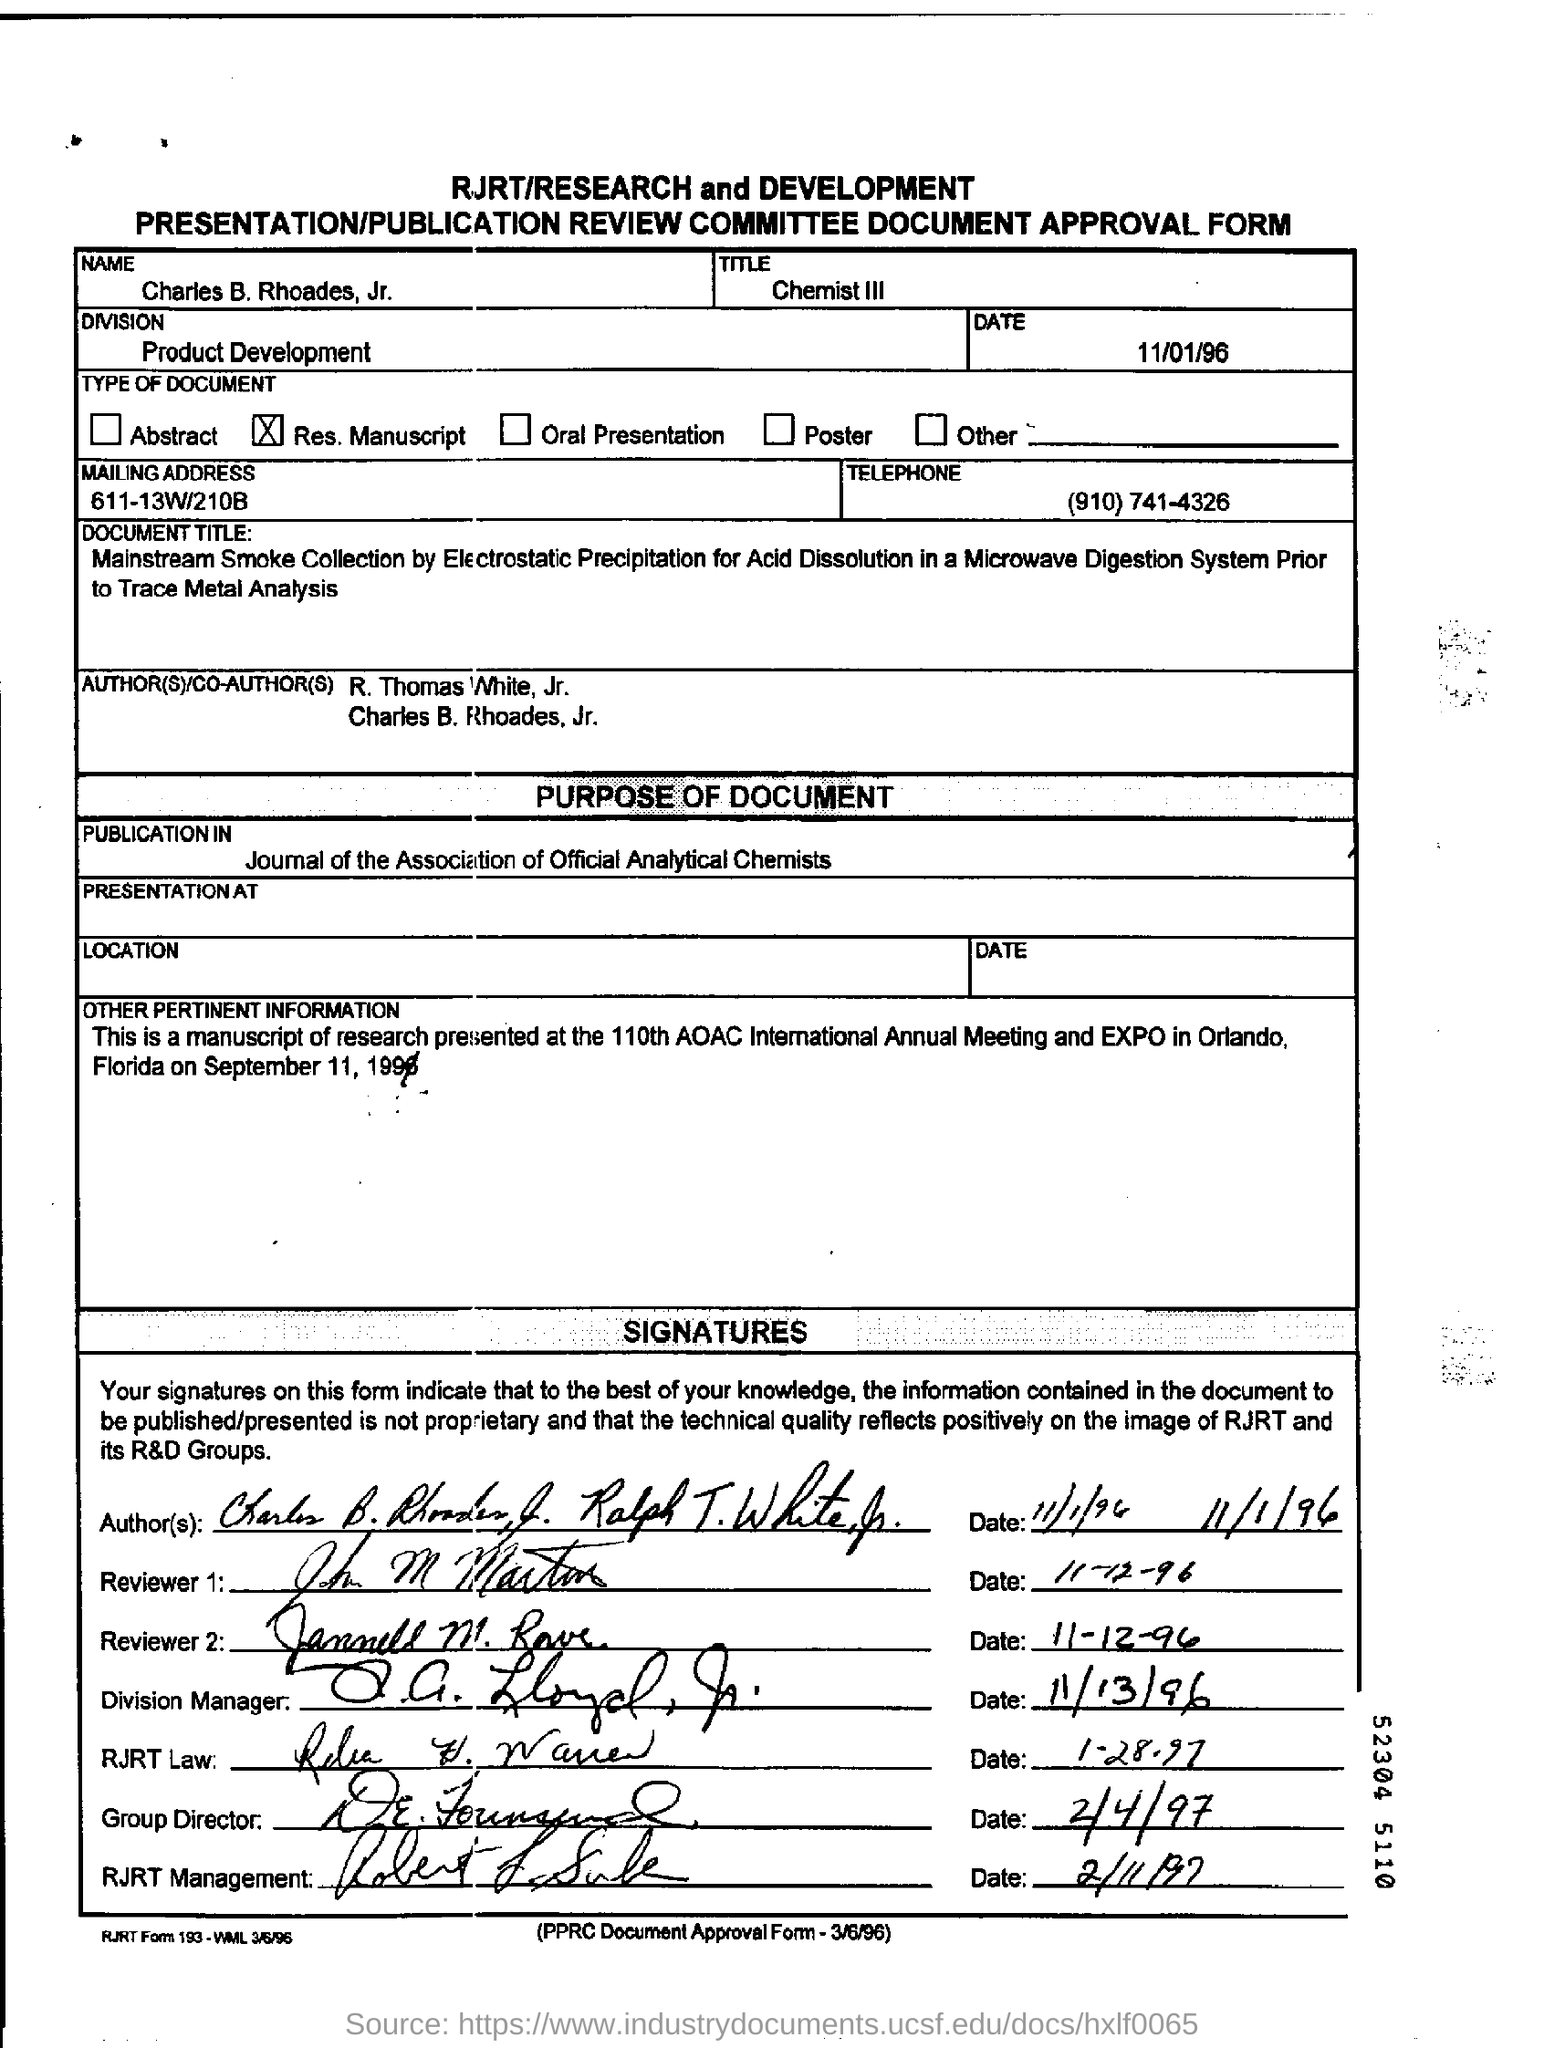Indicate a few pertinent items in this graphic. What is the date?" the speaker asked, with the date being 11/01/96. The name is Charles B. Rhoades, Jr. The Division of Product Development is centered on answering the question of what the division is. The mailing address is 611-13W/210B. 